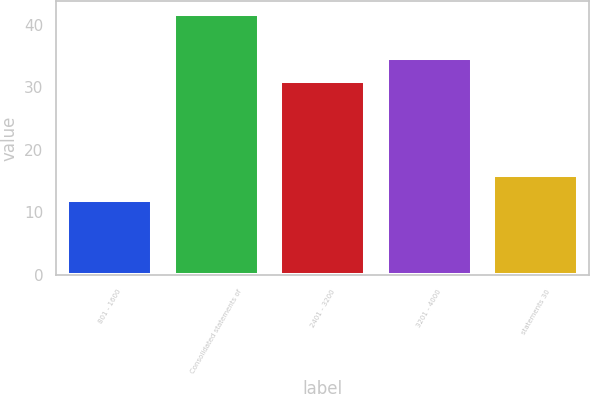<chart> <loc_0><loc_0><loc_500><loc_500><bar_chart><fcel>801 - 1600<fcel>Consolidated statements of<fcel>2401 - 3200<fcel>3201 - 4000<fcel>statements 30<nl><fcel>11.91<fcel>41.67<fcel>31.04<fcel>34.77<fcel>15.96<nl></chart> 